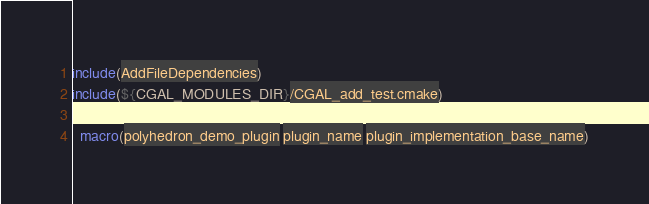Convert code to text. <code><loc_0><loc_0><loc_500><loc_500><_CMake_>include(AddFileDependencies)
include(${CGAL_MODULES_DIR}/CGAL_add_test.cmake)

  macro(polyhedron_demo_plugin plugin_name plugin_implementation_base_name)</code> 